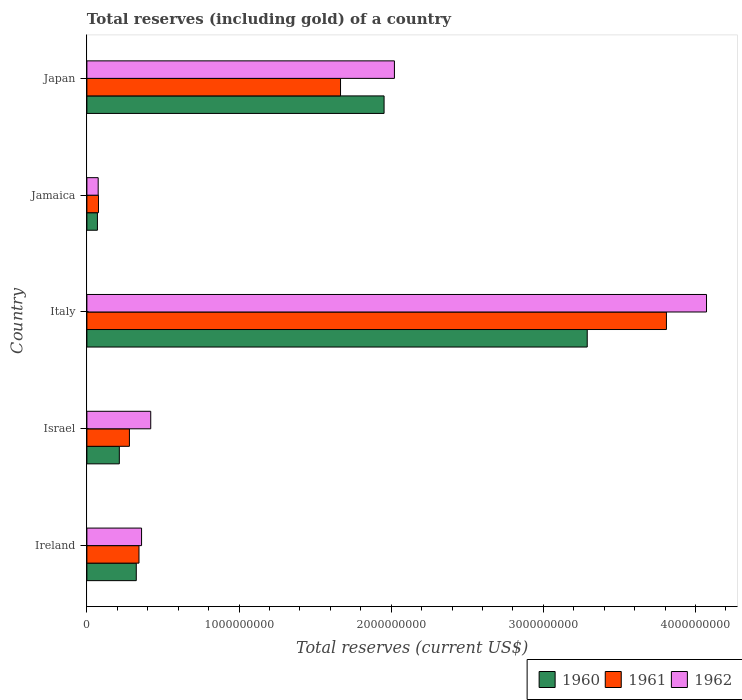How many groups of bars are there?
Keep it short and to the point. 5. How many bars are there on the 2nd tick from the top?
Your answer should be very brief. 3. How many bars are there on the 4th tick from the bottom?
Offer a very short reply. 3. What is the label of the 5th group of bars from the top?
Provide a succinct answer. Ireland. What is the total reserves (including gold) in 1962 in Italy?
Ensure brevity in your answer.  4.07e+09. Across all countries, what is the maximum total reserves (including gold) in 1961?
Your answer should be compact. 3.81e+09. Across all countries, what is the minimum total reserves (including gold) in 1961?
Your answer should be compact. 7.61e+07. In which country was the total reserves (including gold) in 1960 minimum?
Ensure brevity in your answer.  Jamaica. What is the total total reserves (including gold) in 1961 in the graph?
Offer a very short reply. 6.17e+09. What is the difference between the total reserves (including gold) in 1962 in Italy and that in Japan?
Your response must be concise. 2.05e+09. What is the difference between the total reserves (including gold) in 1962 in Japan and the total reserves (including gold) in 1960 in Jamaica?
Give a very brief answer. 1.95e+09. What is the average total reserves (including gold) in 1960 per country?
Keep it short and to the point. 1.17e+09. What is the difference between the total reserves (including gold) in 1960 and total reserves (including gold) in 1962 in Ireland?
Give a very brief answer. -3.47e+07. In how many countries, is the total reserves (including gold) in 1961 greater than 1400000000 US$?
Your answer should be compact. 2. What is the ratio of the total reserves (including gold) in 1961 in Ireland to that in Jamaica?
Your answer should be compact. 4.5. Is the difference between the total reserves (including gold) in 1960 in Israel and Italy greater than the difference between the total reserves (including gold) in 1962 in Israel and Italy?
Provide a short and direct response. Yes. What is the difference between the highest and the second highest total reserves (including gold) in 1962?
Your answer should be very brief. 2.05e+09. What is the difference between the highest and the lowest total reserves (including gold) in 1960?
Offer a very short reply. 3.22e+09. In how many countries, is the total reserves (including gold) in 1961 greater than the average total reserves (including gold) in 1961 taken over all countries?
Offer a very short reply. 2. How many bars are there?
Offer a terse response. 15. Are all the bars in the graph horizontal?
Your answer should be compact. Yes. How many countries are there in the graph?
Give a very brief answer. 5. Does the graph contain any zero values?
Provide a short and direct response. No. How are the legend labels stacked?
Your answer should be very brief. Horizontal. What is the title of the graph?
Your response must be concise. Total reserves (including gold) of a country. What is the label or title of the X-axis?
Ensure brevity in your answer.  Total reserves (current US$). What is the label or title of the Y-axis?
Provide a short and direct response. Country. What is the Total reserves (current US$) of 1960 in Ireland?
Your answer should be very brief. 3.25e+08. What is the Total reserves (current US$) in 1961 in Ireland?
Provide a short and direct response. 3.42e+08. What is the Total reserves (current US$) in 1962 in Ireland?
Offer a terse response. 3.59e+08. What is the Total reserves (current US$) in 1960 in Israel?
Offer a terse response. 2.13e+08. What is the Total reserves (current US$) in 1961 in Israel?
Your answer should be very brief. 2.80e+08. What is the Total reserves (current US$) in 1962 in Israel?
Keep it short and to the point. 4.20e+08. What is the Total reserves (current US$) of 1960 in Italy?
Offer a very short reply. 3.29e+09. What is the Total reserves (current US$) in 1961 in Italy?
Offer a terse response. 3.81e+09. What is the Total reserves (current US$) in 1962 in Italy?
Keep it short and to the point. 4.07e+09. What is the Total reserves (current US$) in 1960 in Jamaica?
Make the answer very short. 6.92e+07. What is the Total reserves (current US$) of 1961 in Jamaica?
Provide a succinct answer. 7.61e+07. What is the Total reserves (current US$) in 1962 in Jamaica?
Provide a short and direct response. 7.42e+07. What is the Total reserves (current US$) of 1960 in Japan?
Your answer should be compact. 1.95e+09. What is the Total reserves (current US$) in 1961 in Japan?
Your answer should be very brief. 1.67e+09. What is the Total reserves (current US$) in 1962 in Japan?
Provide a succinct answer. 2.02e+09. Across all countries, what is the maximum Total reserves (current US$) in 1960?
Offer a very short reply. 3.29e+09. Across all countries, what is the maximum Total reserves (current US$) of 1961?
Offer a very short reply. 3.81e+09. Across all countries, what is the maximum Total reserves (current US$) of 1962?
Give a very brief answer. 4.07e+09. Across all countries, what is the minimum Total reserves (current US$) in 1960?
Offer a terse response. 6.92e+07. Across all countries, what is the minimum Total reserves (current US$) in 1961?
Offer a very short reply. 7.61e+07. Across all countries, what is the minimum Total reserves (current US$) in 1962?
Provide a short and direct response. 7.42e+07. What is the total Total reserves (current US$) of 1960 in the graph?
Provide a succinct answer. 5.85e+09. What is the total Total reserves (current US$) in 1961 in the graph?
Your answer should be compact. 6.17e+09. What is the total Total reserves (current US$) in 1962 in the graph?
Make the answer very short. 6.95e+09. What is the difference between the Total reserves (current US$) of 1960 in Ireland and that in Israel?
Your response must be concise. 1.11e+08. What is the difference between the Total reserves (current US$) in 1961 in Ireland and that in Israel?
Offer a very short reply. 6.28e+07. What is the difference between the Total reserves (current US$) in 1962 in Ireland and that in Israel?
Make the answer very short. -6.03e+07. What is the difference between the Total reserves (current US$) in 1960 in Ireland and that in Italy?
Offer a very short reply. -2.96e+09. What is the difference between the Total reserves (current US$) of 1961 in Ireland and that in Italy?
Provide a short and direct response. -3.47e+09. What is the difference between the Total reserves (current US$) in 1962 in Ireland and that in Italy?
Ensure brevity in your answer.  -3.71e+09. What is the difference between the Total reserves (current US$) in 1960 in Ireland and that in Jamaica?
Your response must be concise. 2.55e+08. What is the difference between the Total reserves (current US$) of 1961 in Ireland and that in Jamaica?
Your answer should be compact. 2.66e+08. What is the difference between the Total reserves (current US$) in 1962 in Ireland and that in Jamaica?
Make the answer very short. 2.85e+08. What is the difference between the Total reserves (current US$) in 1960 in Ireland and that in Japan?
Keep it short and to the point. -1.63e+09. What is the difference between the Total reserves (current US$) of 1961 in Ireland and that in Japan?
Give a very brief answer. -1.32e+09. What is the difference between the Total reserves (current US$) of 1962 in Ireland and that in Japan?
Your answer should be compact. -1.66e+09. What is the difference between the Total reserves (current US$) of 1960 in Israel and that in Italy?
Offer a very short reply. -3.08e+09. What is the difference between the Total reserves (current US$) of 1961 in Israel and that in Italy?
Provide a succinct answer. -3.53e+09. What is the difference between the Total reserves (current US$) in 1962 in Israel and that in Italy?
Your response must be concise. -3.65e+09. What is the difference between the Total reserves (current US$) of 1960 in Israel and that in Jamaica?
Offer a terse response. 1.44e+08. What is the difference between the Total reserves (current US$) in 1961 in Israel and that in Jamaica?
Offer a terse response. 2.03e+08. What is the difference between the Total reserves (current US$) of 1962 in Israel and that in Jamaica?
Offer a terse response. 3.45e+08. What is the difference between the Total reserves (current US$) in 1960 in Israel and that in Japan?
Your answer should be compact. -1.74e+09. What is the difference between the Total reserves (current US$) in 1961 in Israel and that in Japan?
Your answer should be very brief. -1.39e+09. What is the difference between the Total reserves (current US$) of 1962 in Israel and that in Japan?
Ensure brevity in your answer.  -1.60e+09. What is the difference between the Total reserves (current US$) in 1960 in Italy and that in Jamaica?
Make the answer very short. 3.22e+09. What is the difference between the Total reserves (current US$) of 1961 in Italy and that in Jamaica?
Offer a terse response. 3.73e+09. What is the difference between the Total reserves (current US$) in 1962 in Italy and that in Jamaica?
Make the answer very short. 4.00e+09. What is the difference between the Total reserves (current US$) in 1960 in Italy and that in Japan?
Ensure brevity in your answer.  1.34e+09. What is the difference between the Total reserves (current US$) of 1961 in Italy and that in Japan?
Your response must be concise. 2.14e+09. What is the difference between the Total reserves (current US$) in 1962 in Italy and that in Japan?
Give a very brief answer. 2.05e+09. What is the difference between the Total reserves (current US$) in 1960 in Jamaica and that in Japan?
Give a very brief answer. -1.88e+09. What is the difference between the Total reserves (current US$) in 1961 in Jamaica and that in Japan?
Provide a short and direct response. -1.59e+09. What is the difference between the Total reserves (current US$) in 1962 in Jamaica and that in Japan?
Your answer should be compact. -1.95e+09. What is the difference between the Total reserves (current US$) in 1960 in Ireland and the Total reserves (current US$) in 1961 in Israel?
Give a very brief answer. 4.51e+07. What is the difference between the Total reserves (current US$) of 1960 in Ireland and the Total reserves (current US$) of 1962 in Israel?
Ensure brevity in your answer.  -9.51e+07. What is the difference between the Total reserves (current US$) of 1961 in Ireland and the Total reserves (current US$) of 1962 in Israel?
Provide a succinct answer. -7.73e+07. What is the difference between the Total reserves (current US$) of 1960 in Ireland and the Total reserves (current US$) of 1961 in Italy?
Provide a short and direct response. -3.48e+09. What is the difference between the Total reserves (current US$) of 1960 in Ireland and the Total reserves (current US$) of 1962 in Italy?
Provide a succinct answer. -3.75e+09. What is the difference between the Total reserves (current US$) in 1961 in Ireland and the Total reserves (current US$) in 1962 in Italy?
Ensure brevity in your answer.  -3.73e+09. What is the difference between the Total reserves (current US$) of 1960 in Ireland and the Total reserves (current US$) of 1961 in Jamaica?
Offer a terse response. 2.48e+08. What is the difference between the Total reserves (current US$) in 1960 in Ireland and the Total reserves (current US$) in 1962 in Jamaica?
Provide a short and direct response. 2.50e+08. What is the difference between the Total reserves (current US$) of 1961 in Ireland and the Total reserves (current US$) of 1962 in Jamaica?
Ensure brevity in your answer.  2.68e+08. What is the difference between the Total reserves (current US$) in 1960 in Ireland and the Total reserves (current US$) in 1961 in Japan?
Ensure brevity in your answer.  -1.34e+09. What is the difference between the Total reserves (current US$) of 1960 in Ireland and the Total reserves (current US$) of 1962 in Japan?
Offer a terse response. -1.70e+09. What is the difference between the Total reserves (current US$) in 1961 in Ireland and the Total reserves (current US$) in 1962 in Japan?
Ensure brevity in your answer.  -1.68e+09. What is the difference between the Total reserves (current US$) in 1960 in Israel and the Total reserves (current US$) in 1961 in Italy?
Ensure brevity in your answer.  -3.60e+09. What is the difference between the Total reserves (current US$) of 1960 in Israel and the Total reserves (current US$) of 1962 in Italy?
Offer a terse response. -3.86e+09. What is the difference between the Total reserves (current US$) in 1961 in Israel and the Total reserves (current US$) in 1962 in Italy?
Provide a short and direct response. -3.79e+09. What is the difference between the Total reserves (current US$) in 1960 in Israel and the Total reserves (current US$) in 1961 in Jamaica?
Make the answer very short. 1.37e+08. What is the difference between the Total reserves (current US$) in 1960 in Israel and the Total reserves (current US$) in 1962 in Jamaica?
Make the answer very short. 1.39e+08. What is the difference between the Total reserves (current US$) of 1961 in Israel and the Total reserves (current US$) of 1962 in Jamaica?
Provide a succinct answer. 2.05e+08. What is the difference between the Total reserves (current US$) of 1960 in Israel and the Total reserves (current US$) of 1961 in Japan?
Your response must be concise. -1.45e+09. What is the difference between the Total reserves (current US$) in 1960 in Israel and the Total reserves (current US$) in 1962 in Japan?
Ensure brevity in your answer.  -1.81e+09. What is the difference between the Total reserves (current US$) of 1961 in Israel and the Total reserves (current US$) of 1962 in Japan?
Offer a very short reply. -1.74e+09. What is the difference between the Total reserves (current US$) in 1960 in Italy and the Total reserves (current US$) in 1961 in Jamaica?
Keep it short and to the point. 3.21e+09. What is the difference between the Total reserves (current US$) of 1960 in Italy and the Total reserves (current US$) of 1962 in Jamaica?
Provide a succinct answer. 3.21e+09. What is the difference between the Total reserves (current US$) in 1961 in Italy and the Total reserves (current US$) in 1962 in Jamaica?
Your response must be concise. 3.74e+09. What is the difference between the Total reserves (current US$) of 1960 in Italy and the Total reserves (current US$) of 1961 in Japan?
Your answer should be very brief. 1.62e+09. What is the difference between the Total reserves (current US$) in 1960 in Italy and the Total reserves (current US$) in 1962 in Japan?
Your response must be concise. 1.27e+09. What is the difference between the Total reserves (current US$) in 1961 in Italy and the Total reserves (current US$) in 1962 in Japan?
Provide a short and direct response. 1.79e+09. What is the difference between the Total reserves (current US$) in 1960 in Jamaica and the Total reserves (current US$) in 1961 in Japan?
Keep it short and to the point. -1.60e+09. What is the difference between the Total reserves (current US$) of 1960 in Jamaica and the Total reserves (current US$) of 1962 in Japan?
Keep it short and to the point. -1.95e+09. What is the difference between the Total reserves (current US$) in 1961 in Jamaica and the Total reserves (current US$) in 1962 in Japan?
Offer a very short reply. -1.95e+09. What is the average Total reserves (current US$) of 1960 per country?
Ensure brevity in your answer.  1.17e+09. What is the average Total reserves (current US$) in 1961 per country?
Ensure brevity in your answer.  1.23e+09. What is the average Total reserves (current US$) in 1962 per country?
Keep it short and to the point. 1.39e+09. What is the difference between the Total reserves (current US$) in 1960 and Total reserves (current US$) in 1961 in Ireland?
Offer a terse response. -1.78e+07. What is the difference between the Total reserves (current US$) of 1960 and Total reserves (current US$) of 1962 in Ireland?
Your response must be concise. -3.47e+07. What is the difference between the Total reserves (current US$) in 1961 and Total reserves (current US$) in 1962 in Ireland?
Keep it short and to the point. -1.70e+07. What is the difference between the Total reserves (current US$) in 1960 and Total reserves (current US$) in 1961 in Israel?
Keep it short and to the point. -6.64e+07. What is the difference between the Total reserves (current US$) in 1960 and Total reserves (current US$) in 1962 in Israel?
Keep it short and to the point. -2.06e+08. What is the difference between the Total reserves (current US$) in 1961 and Total reserves (current US$) in 1962 in Israel?
Offer a very short reply. -1.40e+08. What is the difference between the Total reserves (current US$) in 1960 and Total reserves (current US$) in 1961 in Italy?
Offer a very short reply. -5.21e+08. What is the difference between the Total reserves (current US$) in 1960 and Total reserves (current US$) in 1962 in Italy?
Your response must be concise. -7.84e+08. What is the difference between the Total reserves (current US$) of 1961 and Total reserves (current US$) of 1962 in Italy?
Give a very brief answer. -2.63e+08. What is the difference between the Total reserves (current US$) of 1960 and Total reserves (current US$) of 1961 in Jamaica?
Ensure brevity in your answer.  -6.90e+06. What is the difference between the Total reserves (current US$) in 1960 and Total reserves (current US$) in 1962 in Jamaica?
Make the answer very short. -5.00e+06. What is the difference between the Total reserves (current US$) in 1961 and Total reserves (current US$) in 1962 in Jamaica?
Make the answer very short. 1.90e+06. What is the difference between the Total reserves (current US$) of 1960 and Total reserves (current US$) of 1961 in Japan?
Make the answer very short. 2.86e+08. What is the difference between the Total reserves (current US$) of 1960 and Total reserves (current US$) of 1962 in Japan?
Your response must be concise. -6.80e+07. What is the difference between the Total reserves (current US$) in 1961 and Total reserves (current US$) in 1962 in Japan?
Offer a terse response. -3.54e+08. What is the ratio of the Total reserves (current US$) of 1960 in Ireland to that in Israel?
Give a very brief answer. 1.52. What is the ratio of the Total reserves (current US$) in 1961 in Ireland to that in Israel?
Give a very brief answer. 1.22. What is the ratio of the Total reserves (current US$) in 1962 in Ireland to that in Israel?
Make the answer very short. 0.86. What is the ratio of the Total reserves (current US$) of 1960 in Ireland to that in Italy?
Your response must be concise. 0.1. What is the ratio of the Total reserves (current US$) of 1961 in Ireland to that in Italy?
Provide a succinct answer. 0.09. What is the ratio of the Total reserves (current US$) in 1962 in Ireland to that in Italy?
Ensure brevity in your answer.  0.09. What is the ratio of the Total reserves (current US$) of 1960 in Ireland to that in Jamaica?
Offer a terse response. 4.69. What is the ratio of the Total reserves (current US$) in 1961 in Ireland to that in Jamaica?
Offer a terse response. 4.5. What is the ratio of the Total reserves (current US$) in 1962 in Ireland to that in Jamaica?
Keep it short and to the point. 4.84. What is the ratio of the Total reserves (current US$) of 1960 in Ireland to that in Japan?
Make the answer very short. 0.17. What is the ratio of the Total reserves (current US$) of 1961 in Ireland to that in Japan?
Offer a very short reply. 0.21. What is the ratio of the Total reserves (current US$) in 1962 in Ireland to that in Japan?
Your answer should be very brief. 0.18. What is the ratio of the Total reserves (current US$) of 1960 in Israel to that in Italy?
Provide a short and direct response. 0.06. What is the ratio of the Total reserves (current US$) of 1961 in Israel to that in Italy?
Offer a very short reply. 0.07. What is the ratio of the Total reserves (current US$) of 1962 in Israel to that in Italy?
Your answer should be very brief. 0.1. What is the ratio of the Total reserves (current US$) of 1960 in Israel to that in Jamaica?
Your answer should be compact. 3.08. What is the ratio of the Total reserves (current US$) in 1961 in Israel to that in Jamaica?
Offer a terse response. 3.67. What is the ratio of the Total reserves (current US$) of 1962 in Israel to that in Jamaica?
Give a very brief answer. 5.66. What is the ratio of the Total reserves (current US$) in 1960 in Israel to that in Japan?
Offer a very short reply. 0.11. What is the ratio of the Total reserves (current US$) in 1961 in Israel to that in Japan?
Your answer should be compact. 0.17. What is the ratio of the Total reserves (current US$) of 1962 in Israel to that in Japan?
Keep it short and to the point. 0.21. What is the ratio of the Total reserves (current US$) in 1960 in Italy to that in Jamaica?
Offer a very short reply. 47.52. What is the ratio of the Total reserves (current US$) in 1961 in Italy to that in Jamaica?
Your answer should be very brief. 50.06. What is the ratio of the Total reserves (current US$) in 1962 in Italy to that in Jamaica?
Ensure brevity in your answer.  54.89. What is the ratio of the Total reserves (current US$) of 1960 in Italy to that in Japan?
Provide a short and direct response. 1.68. What is the ratio of the Total reserves (current US$) of 1961 in Italy to that in Japan?
Your answer should be very brief. 2.28. What is the ratio of the Total reserves (current US$) of 1962 in Italy to that in Japan?
Keep it short and to the point. 2.01. What is the ratio of the Total reserves (current US$) of 1960 in Jamaica to that in Japan?
Ensure brevity in your answer.  0.04. What is the ratio of the Total reserves (current US$) in 1961 in Jamaica to that in Japan?
Your answer should be very brief. 0.05. What is the ratio of the Total reserves (current US$) of 1962 in Jamaica to that in Japan?
Provide a succinct answer. 0.04. What is the difference between the highest and the second highest Total reserves (current US$) of 1960?
Provide a succinct answer. 1.34e+09. What is the difference between the highest and the second highest Total reserves (current US$) of 1961?
Offer a very short reply. 2.14e+09. What is the difference between the highest and the second highest Total reserves (current US$) in 1962?
Offer a terse response. 2.05e+09. What is the difference between the highest and the lowest Total reserves (current US$) in 1960?
Make the answer very short. 3.22e+09. What is the difference between the highest and the lowest Total reserves (current US$) in 1961?
Provide a succinct answer. 3.73e+09. What is the difference between the highest and the lowest Total reserves (current US$) of 1962?
Give a very brief answer. 4.00e+09. 